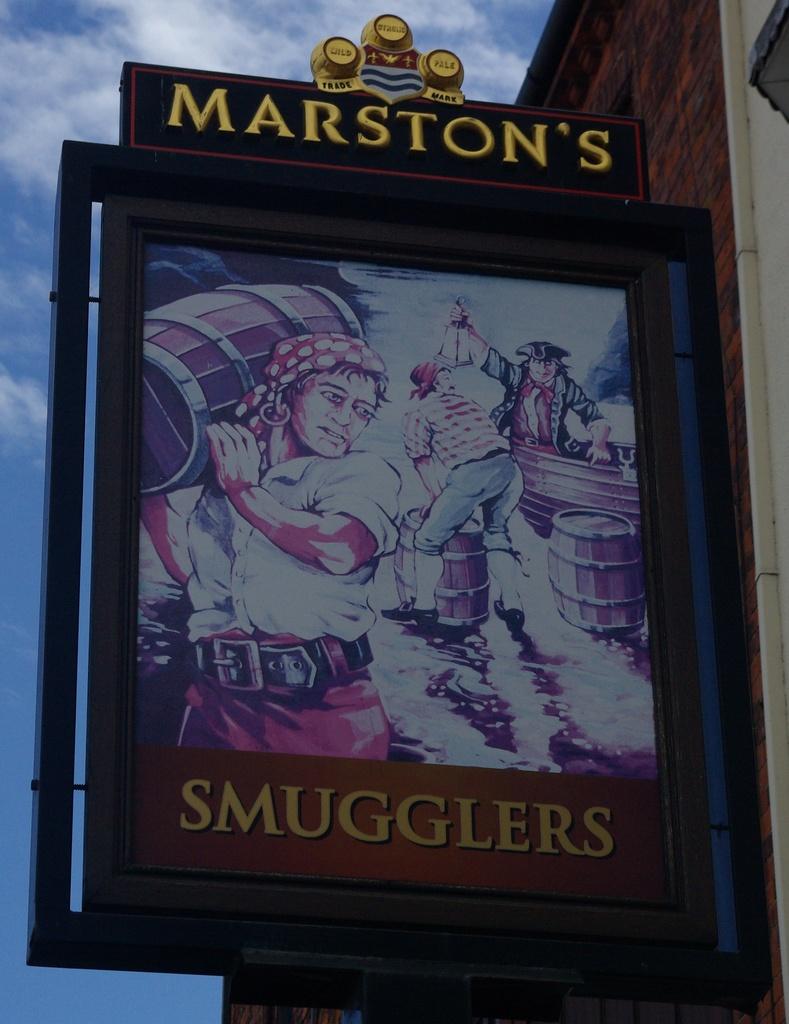What is the title at the bottom of the poster?
Your answer should be very brief. Smugglers. Who  is presenting this event?
Your response must be concise. Marston's. 